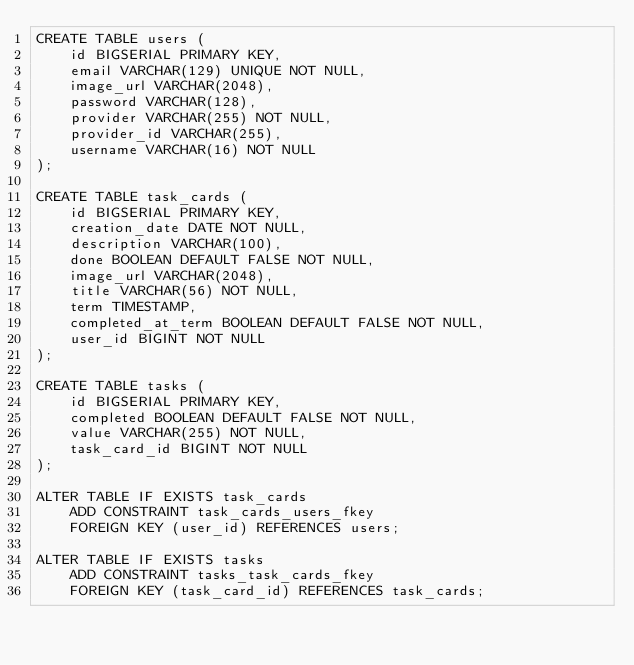<code> <loc_0><loc_0><loc_500><loc_500><_SQL_>CREATE TABLE users (
    id BIGSERIAL PRIMARY KEY,
    email VARCHAR(129) UNIQUE NOT NULL,
    image_url VARCHAR(2048),
    password VARCHAR(128),
    provider VARCHAR(255) NOT NULL,
    provider_id VARCHAR(255),
    username VARCHAR(16) NOT NULL
);

CREATE TABLE task_cards (
    id BIGSERIAL PRIMARY KEY,
    creation_date DATE NOT NULL,
    description VARCHAR(100),
    done BOOLEAN DEFAULT FALSE NOT NULL,
    image_url VARCHAR(2048),
    title VARCHAR(56) NOT NULL,
    term TIMESTAMP,
    completed_at_term BOOLEAN DEFAULT FALSE NOT NULL,
    user_id BIGINT NOT NULL
);

CREATE TABLE tasks (
    id BIGSERIAL PRIMARY KEY,
    completed BOOLEAN DEFAULT FALSE NOT NULL,
    value VARCHAR(255) NOT NULL,
    task_card_id BIGINT NOT NULL
);

ALTER TABLE IF EXISTS task_cards
    ADD CONSTRAINT task_cards_users_fkey
    FOREIGN KEY (user_id) REFERENCES users;

ALTER TABLE IF EXISTS tasks
    ADD CONSTRAINT tasks_task_cards_fkey
    FOREIGN KEY (task_card_id) REFERENCES task_cards;</code> 